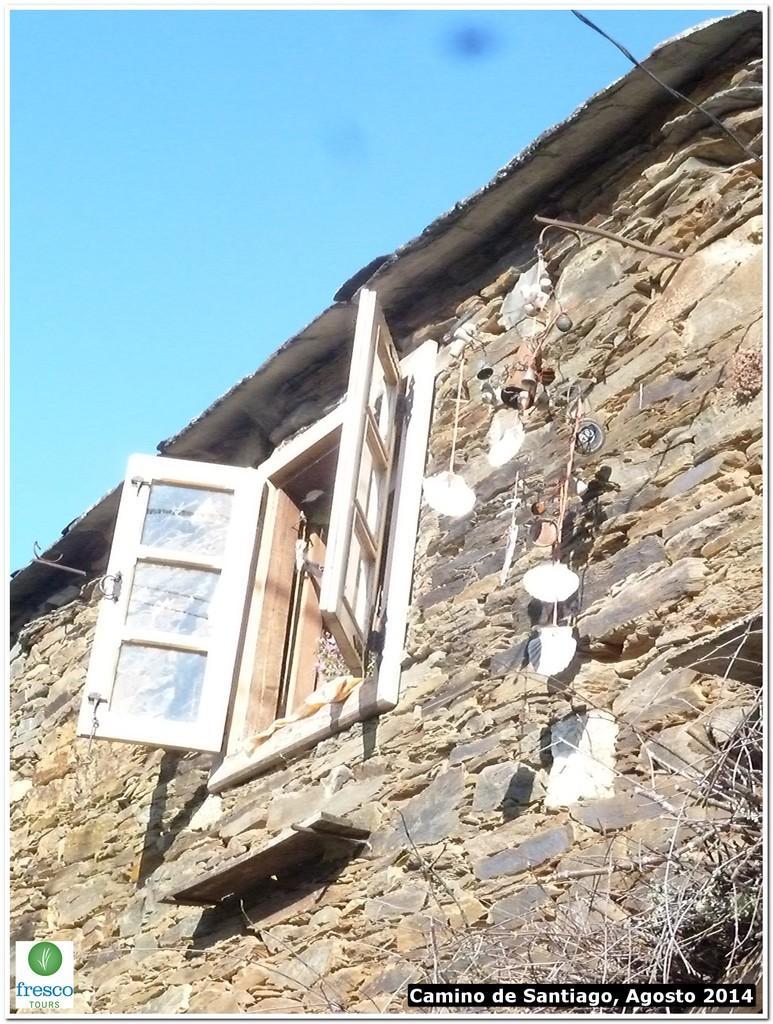How would you summarize this image in a sentence or two? In this image, we can see a wall with windows and some objects. We can also see some wooden sticks on the right. We can also see the sky. 